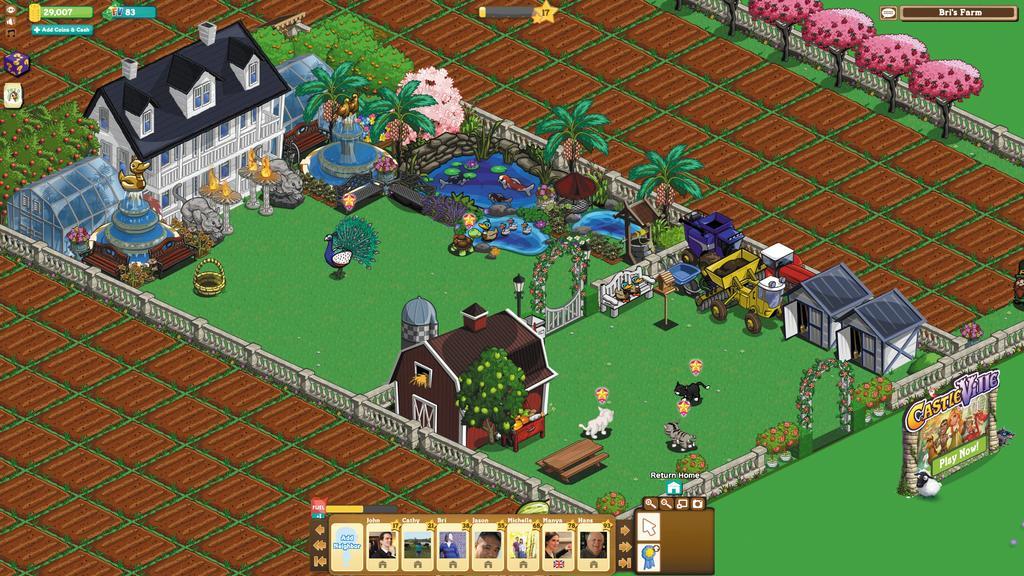How would you summarize this image in a sentence or two? In the foreground of this animated image, we can see houses, trees, fishes in the water, fountains, shed, peacock, basket, grass land, gate, light poles, animals, bench and railing. We can also see farming fields around it and also few buttons and images. 